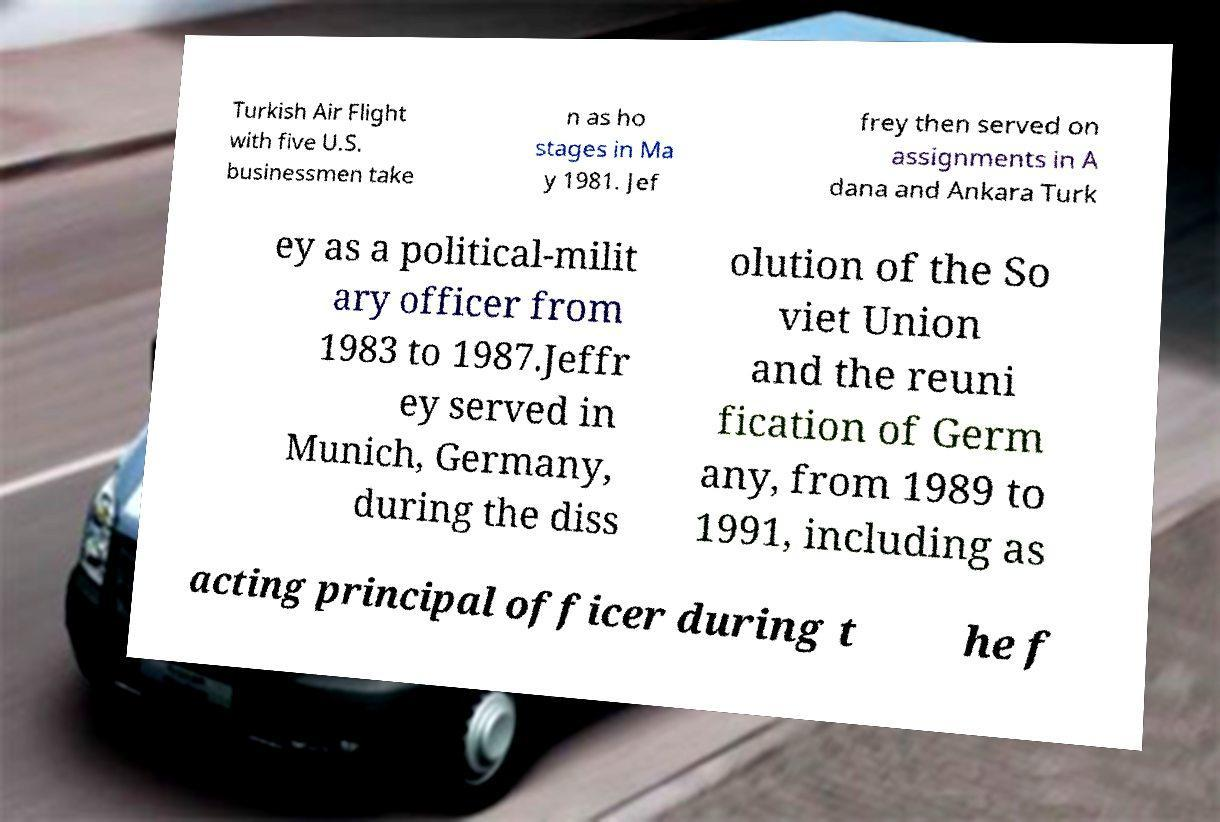There's text embedded in this image that I need extracted. Can you transcribe it verbatim? Turkish Air Flight with five U.S. businessmen take n as ho stages in Ma y 1981. Jef frey then served on assignments in A dana and Ankara Turk ey as a political-milit ary officer from 1983 to 1987.Jeffr ey served in Munich, Germany, during the diss olution of the So viet Union and the reuni fication of Germ any, from 1989 to 1991, including as acting principal officer during t he f 